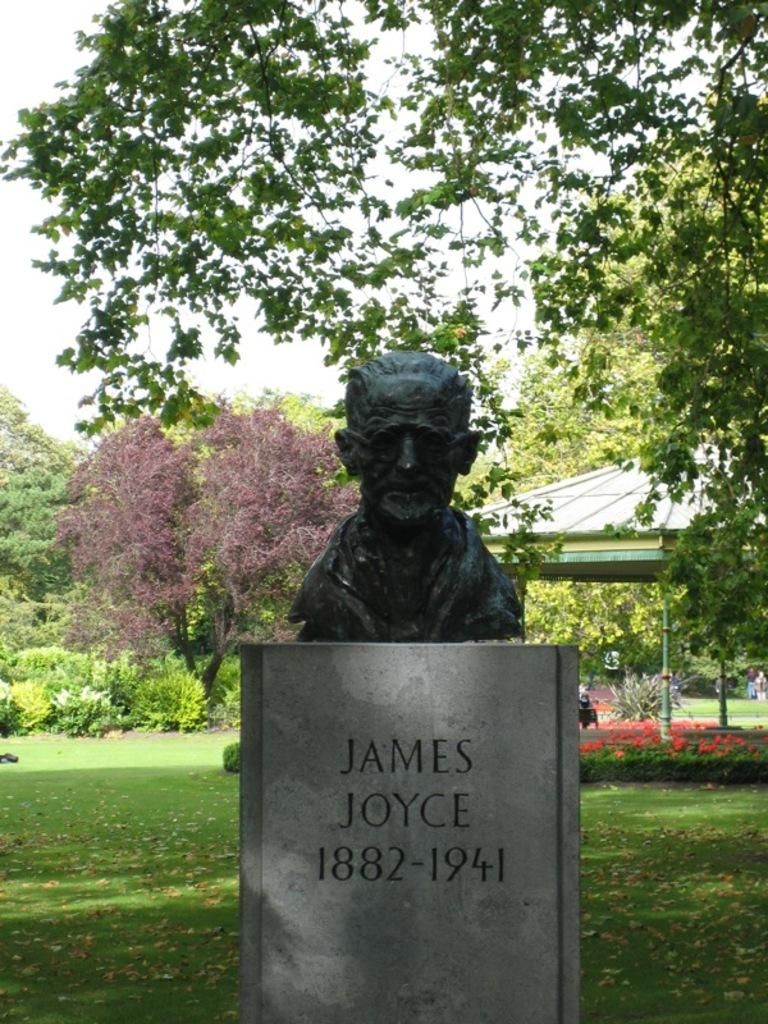What is the main subject in the image? There is a statue in the image. What is written on the stone in the image? There is writing on a stone in the image. What can be seen in the background of the image? Trees, the sky, grass, and objects on the ground are visible in the background of the image. What type of committee is meeting in the hall in the image? There is no hall or committee present in the image; it features a statue and a stone with writing. 